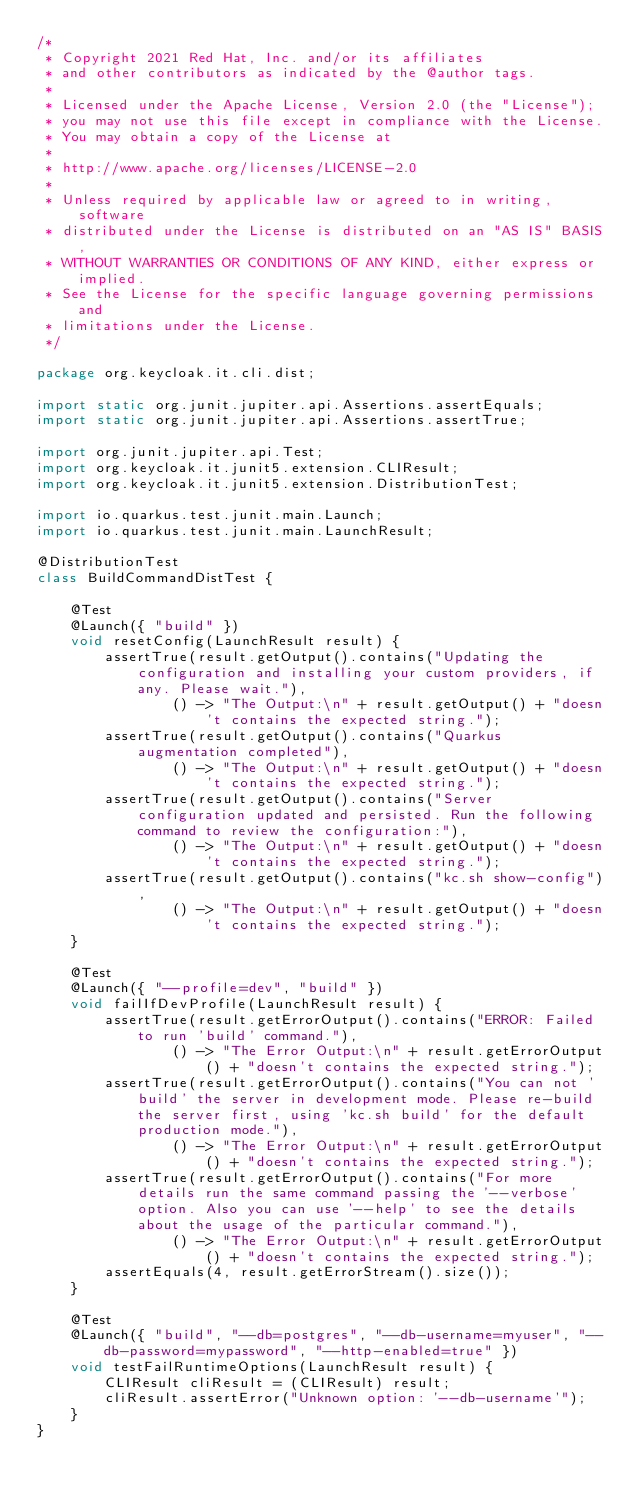<code> <loc_0><loc_0><loc_500><loc_500><_Java_>/*
 * Copyright 2021 Red Hat, Inc. and/or its affiliates
 * and other contributors as indicated by the @author tags.
 *
 * Licensed under the Apache License, Version 2.0 (the "License");
 * you may not use this file except in compliance with the License.
 * You may obtain a copy of the License at
 *
 * http://www.apache.org/licenses/LICENSE-2.0
 *
 * Unless required by applicable law or agreed to in writing, software
 * distributed under the License is distributed on an "AS IS" BASIS,
 * WITHOUT WARRANTIES OR CONDITIONS OF ANY KIND, either express or implied.
 * See the License for the specific language governing permissions and
 * limitations under the License.
 */

package org.keycloak.it.cli.dist;

import static org.junit.jupiter.api.Assertions.assertEquals;
import static org.junit.jupiter.api.Assertions.assertTrue;

import org.junit.jupiter.api.Test;
import org.keycloak.it.junit5.extension.CLIResult;
import org.keycloak.it.junit5.extension.DistributionTest;

import io.quarkus.test.junit.main.Launch;
import io.quarkus.test.junit.main.LaunchResult;

@DistributionTest
class BuildCommandDistTest {

    @Test
    @Launch({ "build" })
    void resetConfig(LaunchResult result) {
        assertTrue(result.getOutput().contains("Updating the configuration and installing your custom providers, if any. Please wait."),
                () -> "The Output:\n" + result.getOutput() + "doesn't contains the expected string.");
        assertTrue(result.getOutput().contains("Quarkus augmentation completed"),
                () -> "The Output:\n" + result.getOutput() + "doesn't contains the expected string.");
        assertTrue(result.getOutput().contains("Server configuration updated and persisted. Run the following command to review the configuration:"),
                () -> "The Output:\n" + result.getOutput() + "doesn't contains the expected string.");
        assertTrue(result.getOutput().contains("kc.sh show-config"),
                () -> "The Output:\n" + result.getOutput() + "doesn't contains the expected string.");
    }

    @Test
    @Launch({ "--profile=dev", "build" })
    void failIfDevProfile(LaunchResult result) {
        assertTrue(result.getErrorOutput().contains("ERROR: Failed to run 'build' command."),
                () -> "The Error Output:\n" + result.getErrorOutput() + "doesn't contains the expected string.");
        assertTrue(result.getErrorOutput().contains("You can not 'build' the server in development mode. Please re-build the server first, using 'kc.sh build' for the default production mode."),
                () -> "The Error Output:\n" + result.getErrorOutput() + "doesn't contains the expected string.");
        assertTrue(result.getErrorOutput().contains("For more details run the same command passing the '--verbose' option. Also you can use '--help' to see the details about the usage of the particular command."),
                () -> "The Error Output:\n" + result.getErrorOutput() + "doesn't contains the expected string.");
        assertEquals(4, result.getErrorStream().size());
    }

    @Test
    @Launch({ "build", "--db=postgres", "--db-username=myuser", "--db-password=mypassword", "--http-enabled=true" })
    void testFailRuntimeOptions(LaunchResult result) {
        CLIResult cliResult = (CLIResult) result;
        cliResult.assertError("Unknown option: '--db-username'");
    }
}
</code> 